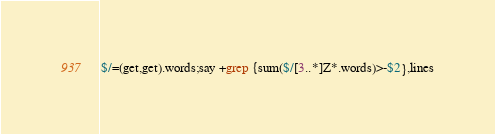<code> <loc_0><loc_0><loc_500><loc_500><_Perl_>$/=(get,get).words;say +grep {sum($/[3..*]Z*.words)>-$2},lines</code> 